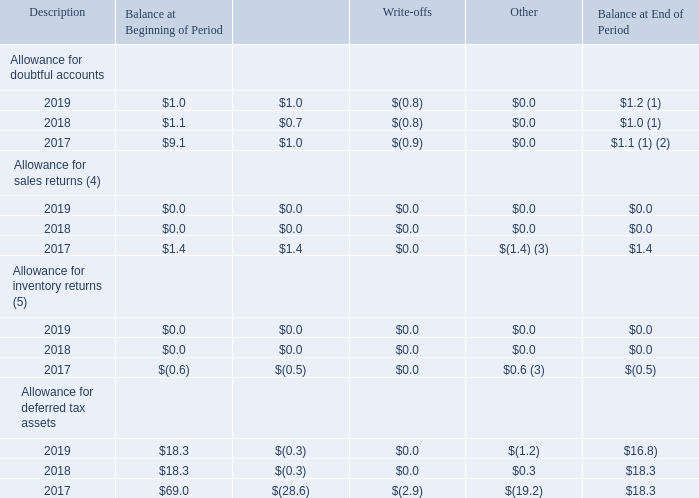SCHEDULE II - VALUATION AND QUALIFYING ACCOUNTS
For the years ended December: (in millions)
(1) Excludes approximately $5.6 million of reserves related to notes receivable and tax refund receivables originated in 2016.
(2) Excludes approximately $0.4 million of reserves related to non-trade receivables.
(3) Amounts represent gross revenue and cost reversals to the estimated sales returns and allowances accounts.
(4) Amounts in 2019 and 2018 are reported within accrued expenses and other current liabilities, as Product Returns Liability (see Note 4 and 9).
(5) Amounts in 2019 and 2018 are reported within prepaid expenses and other current assets.
What is excluded from the 2019 allowance for doubtful accounts? Approximately $5.6 million of reserves related to notes receivable and tax refund receivables originated in 2016. What are excluded from the 2017 allowance for doubtful accounts? Approximately $5.6 million of reserves related to notes receivable and tax refund receivables originated in 2016, approximately $0.4 million of reserves related to non-trade receivables. What does the "other" description in allowance for sales return in 2017 refer to? Gross revenue and cost reversals to the estimated sales returns and allowances accounts. What is the total allowance for doubtful accounts charged to expenses between 2017 to 2019?
Answer scale should be: million. $1.0 + $0.7 + $1.0 
Answer: 2.7. What is the total allowances for sales returns write-offs between 2017 to 2019?
Answer scale should be: million. $0 + $0 + $0 
Answer: 0. What is the percentage change in the allowance for deferred tax assets at the end of period between 2018 and 2019?
Answer scale should be: percent. (16.8 - 18.3)/18.3 
Answer: -8.2. 